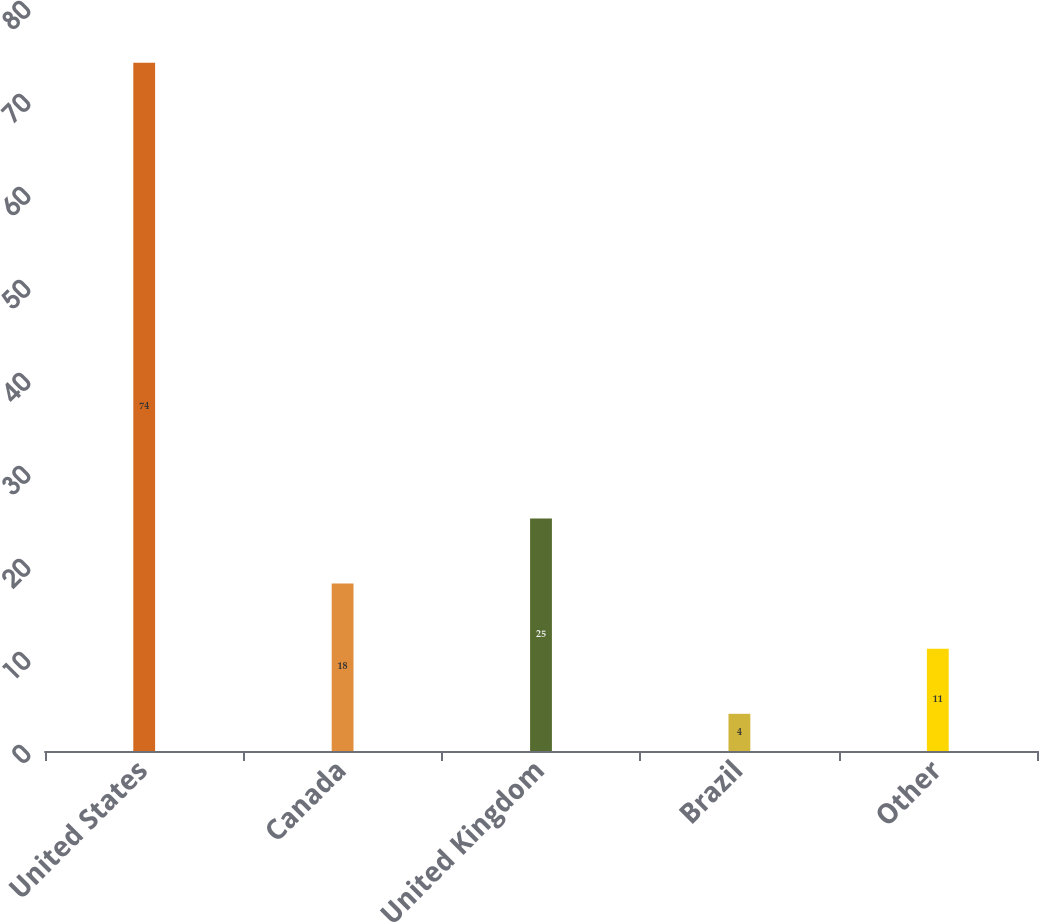Convert chart. <chart><loc_0><loc_0><loc_500><loc_500><bar_chart><fcel>United States<fcel>Canada<fcel>United Kingdom<fcel>Brazil<fcel>Other<nl><fcel>74<fcel>18<fcel>25<fcel>4<fcel>11<nl></chart> 